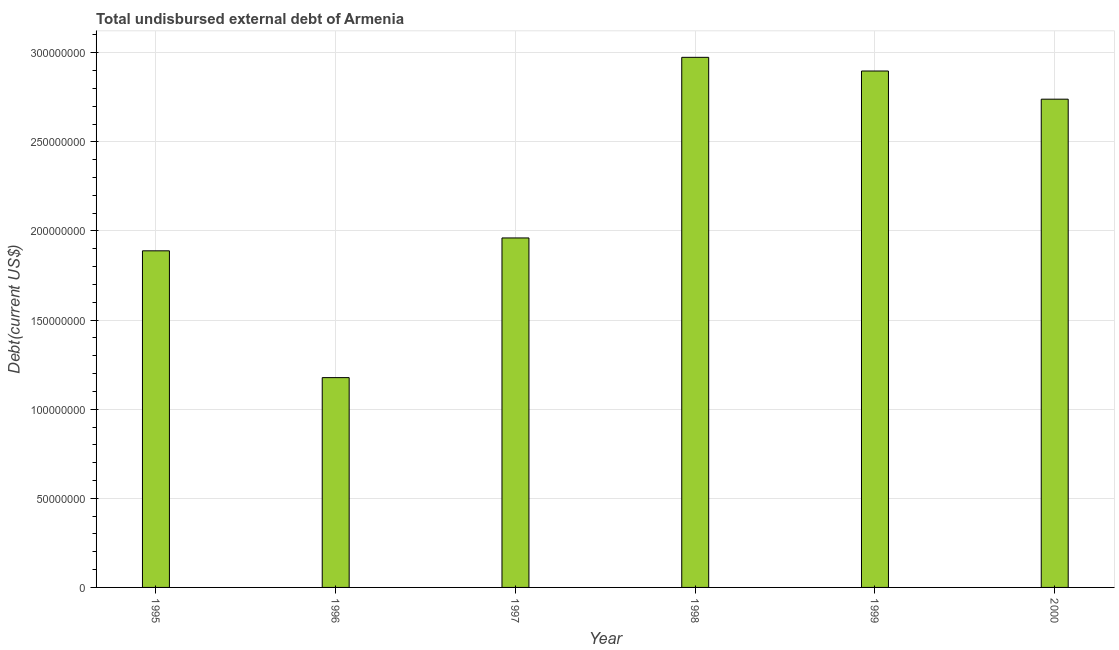Does the graph contain any zero values?
Keep it short and to the point. No. Does the graph contain grids?
Offer a very short reply. Yes. What is the title of the graph?
Your answer should be very brief. Total undisbursed external debt of Armenia. What is the label or title of the X-axis?
Your answer should be very brief. Year. What is the label or title of the Y-axis?
Provide a short and direct response. Debt(current US$). What is the total debt in 1995?
Your response must be concise. 1.89e+08. Across all years, what is the maximum total debt?
Your answer should be compact. 2.97e+08. Across all years, what is the minimum total debt?
Keep it short and to the point. 1.18e+08. In which year was the total debt maximum?
Offer a terse response. 1998. What is the sum of the total debt?
Your answer should be very brief. 1.36e+09. What is the difference between the total debt in 1995 and 2000?
Provide a short and direct response. -8.51e+07. What is the average total debt per year?
Provide a short and direct response. 2.27e+08. What is the median total debt?
Offer a very short reply. 2.35e+08. In how many years, is the total debt greater than 210000000 US$?
Offer a very short reply. 3. What is the ratio of the total debt in 1995 to that in 1996?
Your answer should be very brief. 1.6. Is the difference between the total debt in 1999 and 2000 greater than the difference between any two years?
Provide a short and direct response. No. What is the difference between the highest and the second highest total debt?
Offer a terse response. 7.68e+06. What is the difference between the highest and the lowest total debt?
Ensure brevity in your answer.  1.80e+08. In how many years, is the total debt greater than the average total debt taken over all years?
Provide a short and direct response. 3. What is the Debt(current US$) in 1995?
Your answer should be very brief. 1.89e+08. What is the Debt(current US$) in 1996?
Give a very brief answer. 1.18e+08. What is the Debt(current US$) of 1997?
Provide a short and direct response. 1.96e+08. What is the Debt(current US$) in 1998?
Your response must be concise. 2.97e+08. What is the Debt(current US$) in 1999?
Your answer should be very brief. 2.90e+08. What is the Debt(current US$) in 2000?
Offer a terse response. 2.74e+08. What is the difference between the Debt(current US$) in 1995 and 1996?
Your answer should be very brief. 7.11e+07. What is the difference between the Debt(current US$) in 1995 and 1997?
Offer a very short reply. -7.23e+06. What is the difference between the Debt(current US$) in 1995 and 1998?
Offer a very short reply. -1.09e+08. What is the difference between the Debt(current US$) in 1995 and 1999?
Provide a short and direct response. -1.01e+08. What is the difference between the Debt(current US$) in 1995 and 2000?
Your answer should be compact. -8.51e+07. What is the difference between the Debt(current US$) in 1996 and 1997?
Provide a succinct answer. -7.84e+07. What is the difference between the Debt(current US$) in 1996 and 1998?
Your response must be concise. -1.80e+08. What is the difference between the Debt(current US$) in 1996 and 1999?
Your answer should be very brief. -1.72e+08. What is the difference between the Debt(current US$) in 1996 and 2000?
Make the answer very short. -1.56e+08. What is the difference between the Debt(current US$) in 1997 and 1998?
Your response must be concise. -1.01e+08. What is the difference between the Debt(current US$) in 1997 and 1999?
Make the answer very short. -9.37e+07. What is the difference between the Debt(current US$) in 1997 and 2000?
Ensure brevity in your answer.  -7.79e+07. What is the difference between the Debt(current US$) in 1998 and 1999?
Make the answer very short. 7.68e+06. What is the difference between the Debt(current US$) in 1998 and 2000?
Ensure brevity in your answer.  2.35e+07. What is the difference between the Debt(current US$) in 1999 and 2000?
Ensure brevity in your answer.  1.58e+07. What is the ratio of the Debt(current US$) in 1995 to that in 1996?
Give a very brief answer. 1.6. What is the ratio of the Debt(current US$) in 1995 to that in 1997?
Ensure brevity in your answer.  0.96. What is the ratio of the Debt(current US$) in 1995 to that in 1998?
Provide a succinct answer. 0.64. What is the ratio of the Debt(current US$) in 1995 to that in 1999?
Provide a short and direct response. 0.65. What is the ratio of the Debt(current US$) in 1995 to that in 2000?
Offer a very short reply. 0.69. What is the ratio of the Debt(current US$) in 1996 to that in 1997?
Provide a succinct answer. 0.6. What is the ratio of the Debt(current US$) in 1996 to that in 1998?
Offer a very short reply. 0.4. What is the ratio of the Debt(current US$) in 1996 to that in 1999?
Make the answer very short. 0.41. What is the ratio of the Debt(current US$) in 1996 to that in 2000?
Offer a terse response. 0.43. What is the ratio of the Debt(current US$) in 1997 to that in 1998?
Your answer should be very brief. 0.66. What is the ratio of the Debt(current US$) in 1997 to that in 1999?
Your answer should be very brief. 0.68. What is the ratio of the Debt(current US$) in 1997 to that in 2000?
Make the answer very short. 0.72. What is the ratio of the Debt(current US$) in 1998 to that in 2000?
Ensure brevity in your answer.  1.09. What is the ratio of the Debt(current US$) in 1999 to that in 2000?
Offer a terse response. 1.06. 